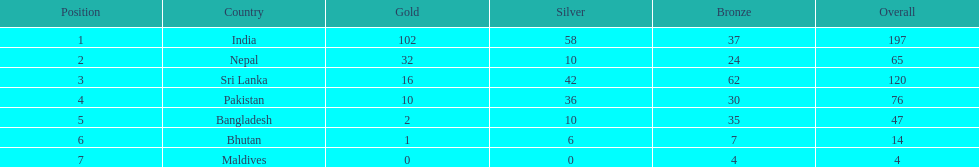What are the total number of bronze medals sri lanka have earned? 62. 